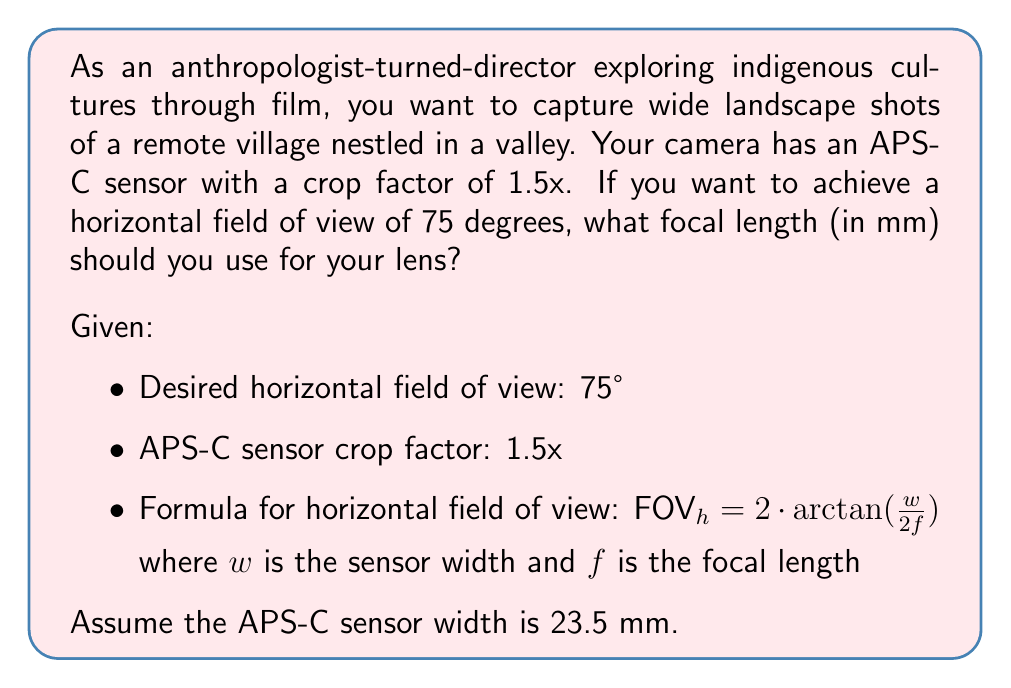Could you help me with this problem? To solve this problem, we'll follow these steps:

1) First, we need to use the formula for the horizontal field of view (FOV):

   $\text{FOV}_h = 2 \cdot \arctan(\frac{w}{2f})$

2) We know the $\text{FOV}_h$ is 75°, and we want to solve for $f$. Let's rearrange the equation:

   $75° = 2 \cdot \arctan(\frac{23.5}{2f})$

3) Divide both sides by 2:

   $37.5° = \arctan(\frac{23.5}{2f})$

4) Take the tangent of both sides:

   $\tan(37.5°) = \frac{23.5}{2f}$

5) Multiply both sides by $2f$:

   $2f \cdot \tan(37.5°) = 23.5$

6) Divide both sides by $\tan(37.5°)$:

   $f = \frac{23.5}{2 \tan(37.5°)}$

7) Calculate the result:

   $f \approx 15.73$ mm

8) However, remember that this is for the APS-C sensor. We need to account for the crop factor of 1.5x to get the equivalent focal length for a full-frame camera:

   $f_{equivalent} = 15.73 \cdot 1.5 \approx 23.60$ mm

9) Round to the nearest standard focal length:

   $f_{equivalent} \approx 24$ mm

Therefore, you should look for a lens with a focal length of approximately 16mm for your APS-C camera, which is equivalent to a 24mm lens on a full-frame camera.
Answer: The optimal lens focal length for capturing wide landscape shots with a 75° horizontal field of view on your APS-C camera is approximately 16mm (which is equivalent to a 24mm lens on a full-frame camera). 